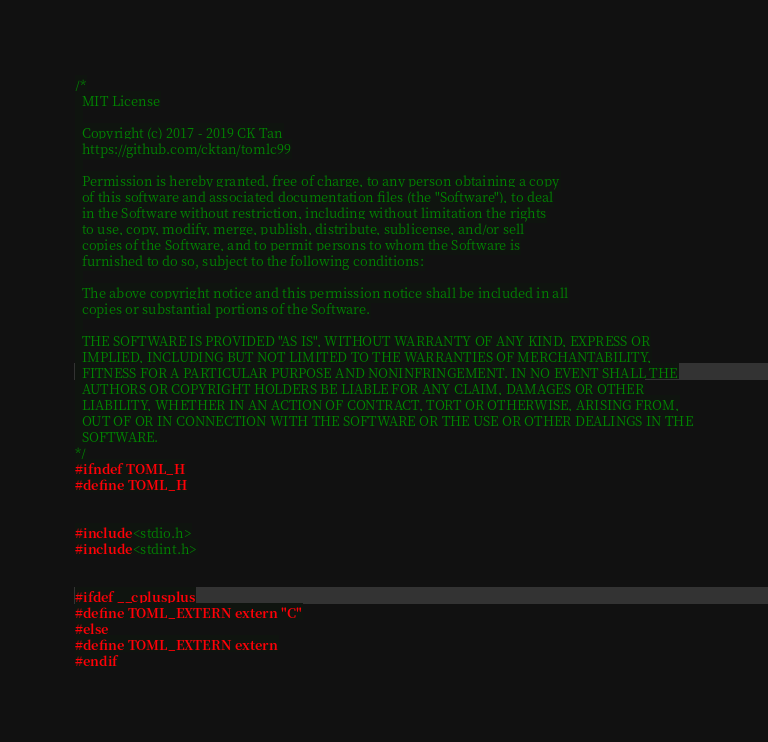<code> <loc_0><loc_0><loc_500><loc_500><_C_>/*
  MIT License
  
  Copyright (c) 2017 - 2019 CK Tan
  https://github.com/cktan/tomlc99
  
  Permission is hereby granted, free of charge, to any person obtaining a copy
  of this software and associated documentation files (the "Software"), to deal
  in the Software without restriction, including without limitation the rights
  to use, copy, modify, merge, publish, distribute, sublicense, and/or sell
  copies of the Software, and to permit persons to whom the Software is
  furnished to do so, subject to the following conditions:
  
  The above copyright notice and this permission notice shall be included in all
  copies or substantial portions of the Software.
  
  THE SOFTWARE IS PROVIDED "AS IS", WITHOUT WARRANTY OF ANY KIND, EXPRESS OR
  IMPLIED, INCLUDING BUT NOT LIMITED TO THE WARRANTIES OF MERCHANTABILITY,
  FITNESS FOR A PARTICULAR PURPOSE AND NONINFRINGEMENT. IN NO EVENT SHALL THE
  AUTHORS OR COPYRIGHT HOLDERS BE LIABLE FOR ANY CLAIM, DAMAGES OR OTHER
  LIABILITY, WHETHER IN AN ACTION OF CONTRACT, TORT OR OTHERWISE, ARISING FROM,
  OUT OF OR IN CONNECTION WITH THE SOFTWARE OR THE USE OR OTHER DEALINGS IN THE
  SOFTWARE.
*/
#ifndef TOML_H
#define TOML_H


#include <stdio.h>
#include <stdint.h>


#ifdef __cplusplus
#define TOML_EXTERN extern "C"
#else
#define TOML_EXTERN extern
#endif
</code> 